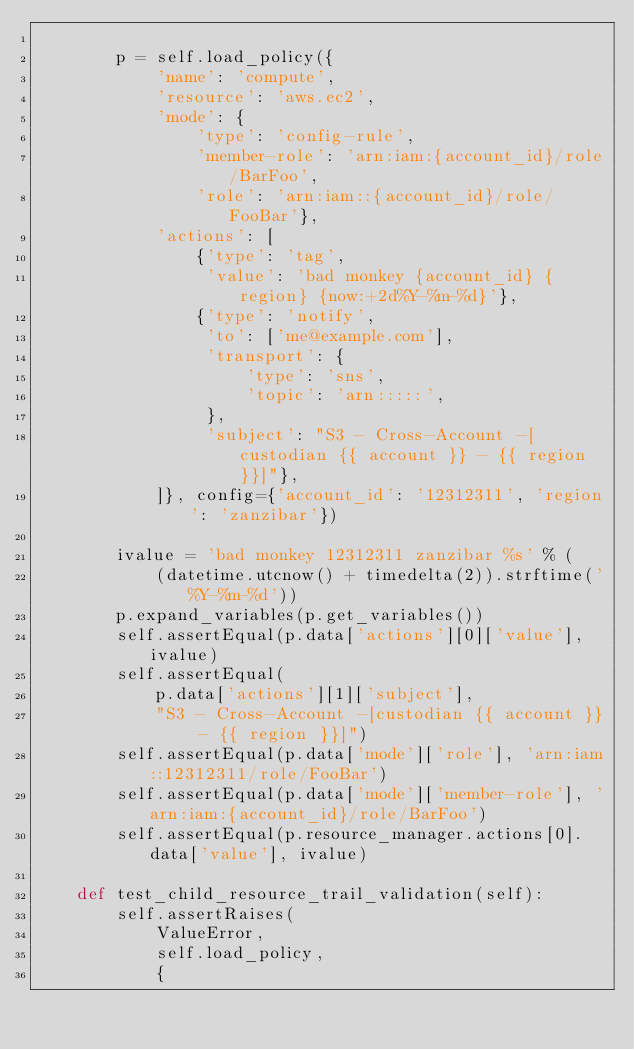Convert code to text. <code><loc_0><loc_0><loc_500><loc_500><_Python_>
        p = self.load_policy({
            'name': 'compute',
            'resource': 'aws.ec2',
            'mode': {
                'type': 'config-rule',
                'member-role': 'arn:iam:{account_id}/role/BarFoo',
                'role': 'arn:iam::{account_id}/role/FooBar'},
            'actions': [
                {'type': 'tag',
                 'value': 'bad monkey {account_id} {region} {now:+2d%Y-%m-%d}'},
                {'type': 'notify',
                 'to': ['me@example.com'],
                 'transport': {
                     'type': 'sns',
                     'topic': 'arn:::::',
                 },
                 'subject': "S3 - Cross-Account -[custodian {{ account }} - {{ region }}]"},
            ]}, config={'account_id': '12312311', 'region': 'zanzibar'})

        ivalue = 'bad monkey 12312311 zanzibar %s' % (
            (datetime.utcnow() + timedelta(2)).strftime('%Y-%m-%d'))
        p.expand_variables(p.get_variables())
        self.assertEqual(p.data['actions'][0]['value'], ivalue)
        self.assertEqual(
            p.data['actions'][1]['subject'],
            "S3 - Cross-Account -[custodian {{ account }} - {{ region }}]")
        self.assertEqual(p.data['mode']['role'], 'arn:iam::12312311/role/FooBar')
        self.assertEqual(p.data['mode']['member-role'], 'arn:iam:{account_id}/role/BarFoo')
        self.assertEqual(p.resource_manager.actions[0].data['value'], ivalue)

    def test_child_resource_trail_validation(self):
        self.assertRaises(
            ValueError,
            self.load_policy,
            {</code> 